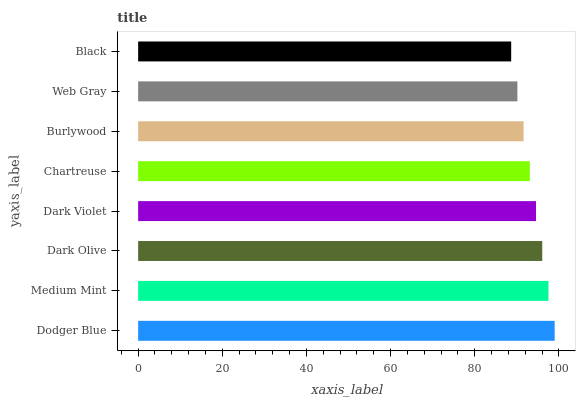Is Black the minimum?
Answer yes or no. Yes. Is Dodger Blue the maximum?
Answer yes or no. Yes. Is Medium Mint the minimum?
Answer yes or no. No. Is Medium Mint the maximum?
Answer yes or no. No. Is Dodger Blue greater than Medium Mint?
Answer yes or no. Yes. Is Medium Mint less than Dodger Blue?
Answer yes or no. Yes. Is Medium Mint greater than Dodger Blue?
Answer yes or no. No. Is Dodger Blue less than Medium Mint?
Answer yes or no. No. Is Dark Violet the high median?
Answer yes or no. Yes. Is Chartreuse the low median?
Answer yes or no. Yes. Is Dark Olive the high median?
Answer yes or no. No. Is Web Gray the low median?
Answer yes or no. No. 